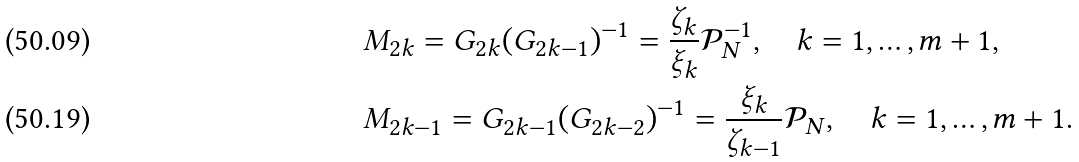Convert formula to latex. <formula><loc_0><loc_0><loc_500><loc_500>& M _ { 2 k } = G _ { 2 k } ( G _ { 2 k - 1 } ) ^ { - 1 } = \frac { \zeta _ { k } } { \xi _ { k } } \mathcal { P } ^ { - 1 } _ { N } , \quad k = 1 , \dots , m + 1 , \\ & M _ { 2 k - 1 } = G _ { 2 k - 1 } ( G _ { 2 k - 2 } ) ^ { - 1 } = \frac { \xi _ { k } } { \zeta _ { k - 1 } } \mathcal { P } _ { N } , \quad k = 1 , \dots , m + 1 .</formula> 